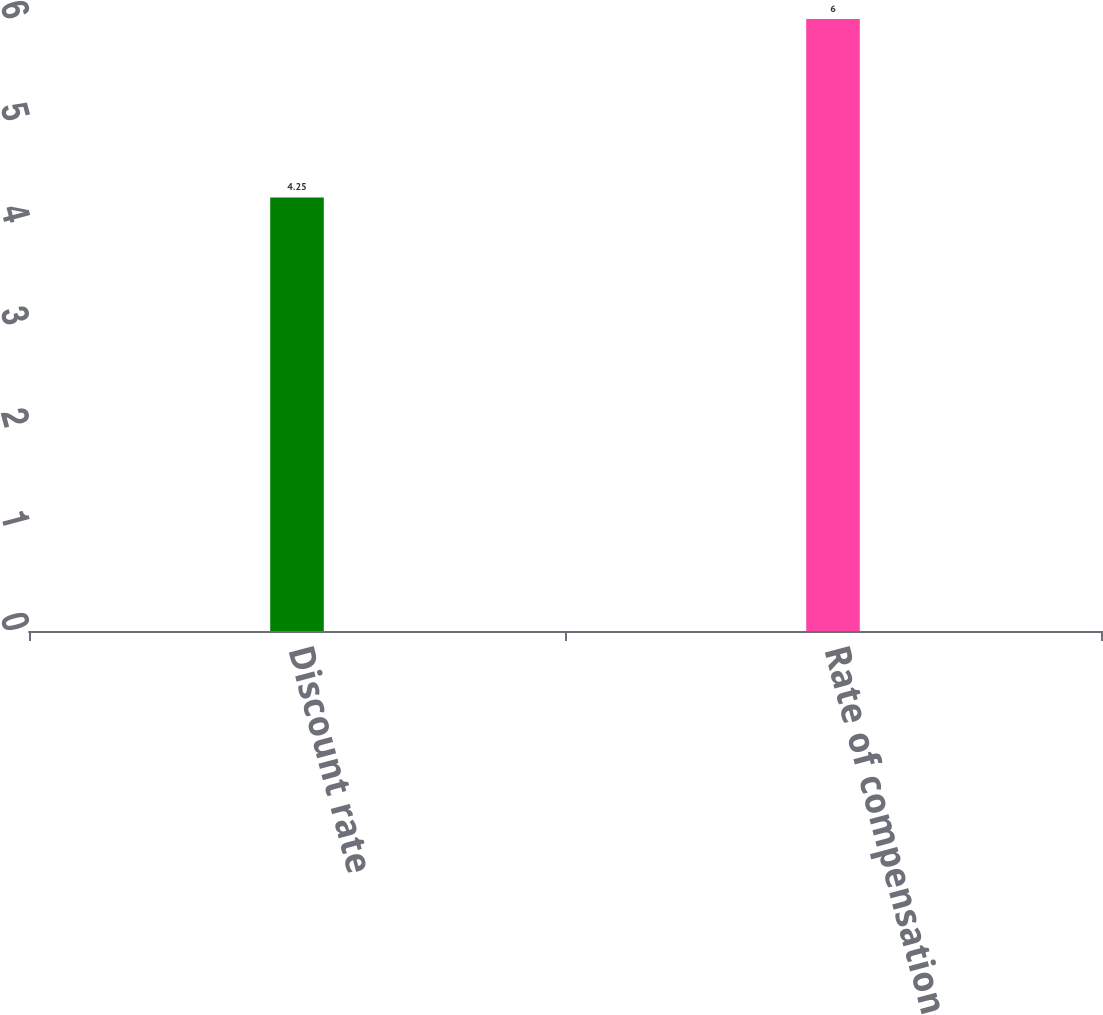<chart> <loc_0><loc_0><loc_500><loc_500><bar_chart><fcel>Discount rate<fcel>Rate of compensation increase<nl><fcel>4.25<fcel>6<nl></chart> 